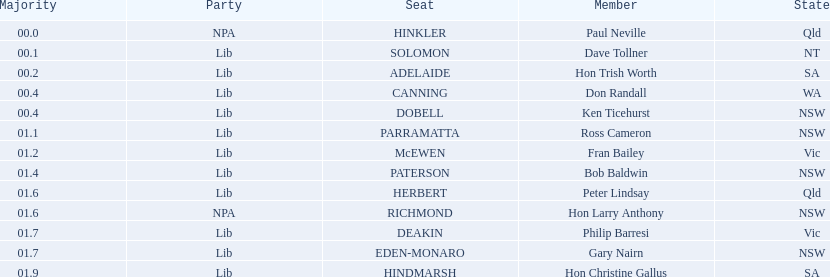Who is listed before don randall? Hon Trish Worth. 